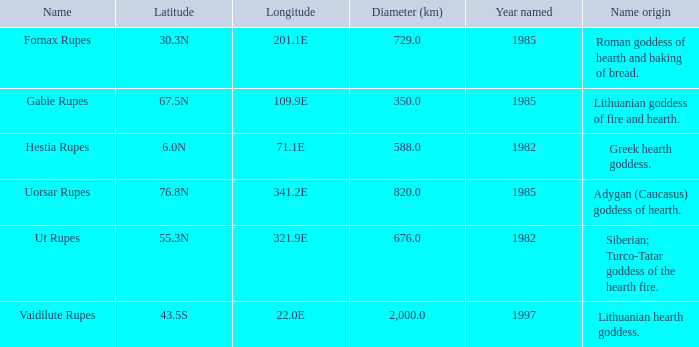When the latitude is 67.5n, what is the corresponding diameter? 350.0. 